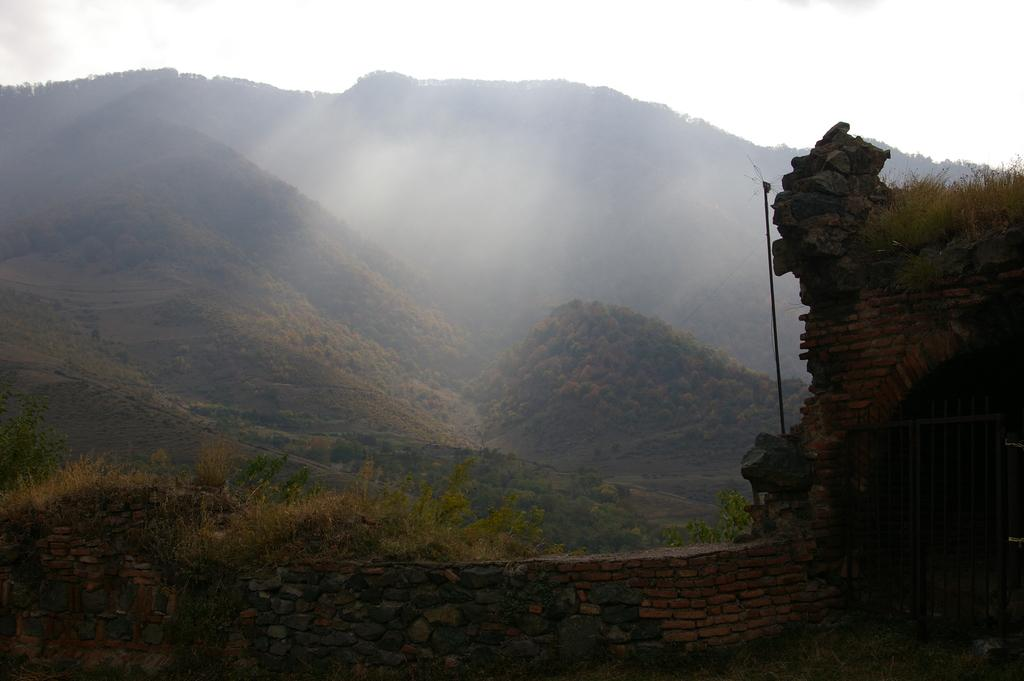What type of natural elements can be seen in the image? There are rocks, plants, trees, and hills visible in the image. Can you describe the vegetation in the image? There are plants and trees in the image. Where is the pole located in the image? The pole is on the right side of the image. What type of prison can be seen in the image? There is no prison present in the image. How does the system work in the image? The image does not depict a system, so it is not possible to describe how it works. 